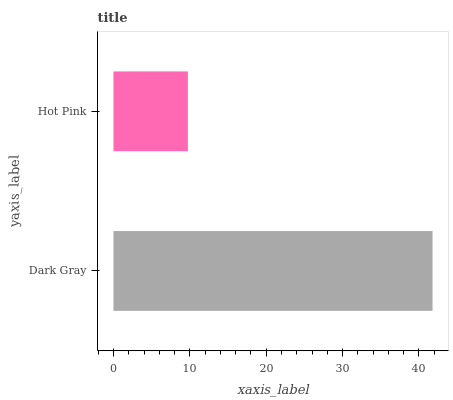Is Hot Pink the minimum?
Answer yes or no. Yes. Is Dark Gray the maximum?
Answer yes or no. Yes. Is Hot Pink the maximum?
Answer yes or no. No. Is Dark Gray greater than Hot Pink?
Answer yes or no. Yes. Is Hot Pink less than Dark Gray?
Answer yes or no. Yes. Is Hot Pink greater than Dark Gray?
Answer yes or no. No. Is Dark Gray less than Hot Pink?
Answer yes or no. No. Is Dark Gray the high median?
Answer yes or no. Yes. Is Hot Pink the low median?
Answer yes or no. Yes. Is Hot Pink the high median?
Answer yes or no. No. Is Dark Gray the low median?
Answer yes or no. No. 